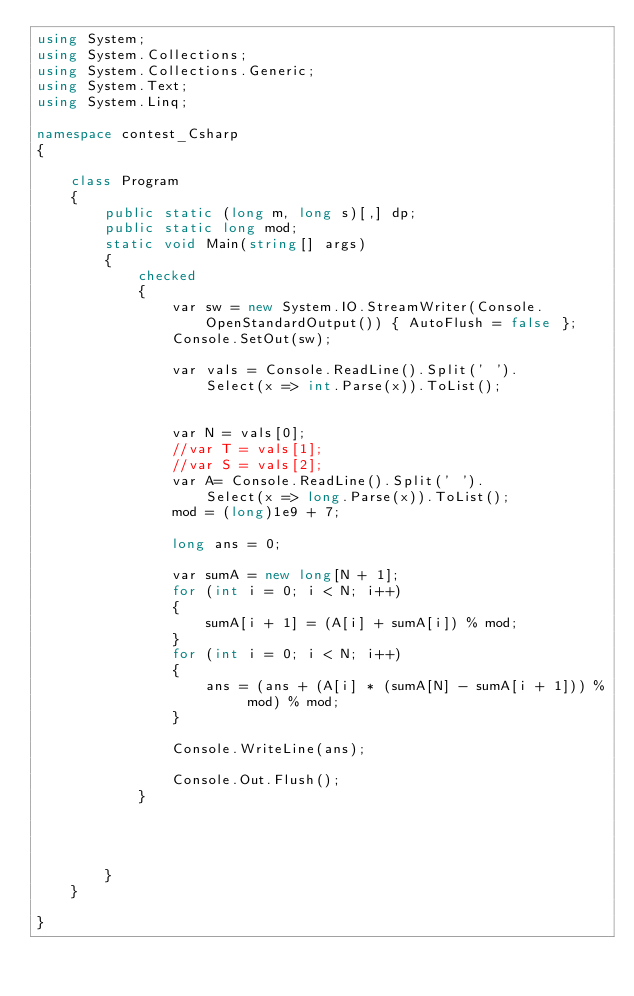<code> <loc_0><loc_0><loc_500><loc_500><_C#_>using System;
using System.Collections;
using System.Collections.Generic;
using System.Text;
using System.Linq;

namespace contest_Csharp
{

    class Program
    {
        public static (long m, long s)[,] dp;
        public static long mod;
        static void Main(string[] args)
        {
            checked
            {
                var sw = new System.IO.StreamWriter(Console.OpenStandardOutput()) { AutoFlush = false };
                Console.SetOut(sw);

                var vals = Console.ReadLine().Split(' ').
                    Select(x => int.Parse(x)).ToList();


                var N = vals[0];
                //var T = vals[1];
                //var S = vals[2];
                var A= Console.ReadLine().Split(' ').
                    Select(x => long.Parse(x)).ToList();
                mod = (long)1e9 + 7;

                long ans = 0;

                var sumA = new long[N + 1];
                for (int i = 0; i < N; i++)
                {
                    sumA[i + 1] = (A[i] + sumA[i]) % mod;
                }
                for (int i = 0; i < N; i++)
                {
                    ans = (ans + (A[i] * (sumA[N] - sumA[i + 1])) % mod) % mod;
                }
                
                Console.WriteLine(ans);

                Console.Out.Flush();
            }




        }
    }

}


</code> 